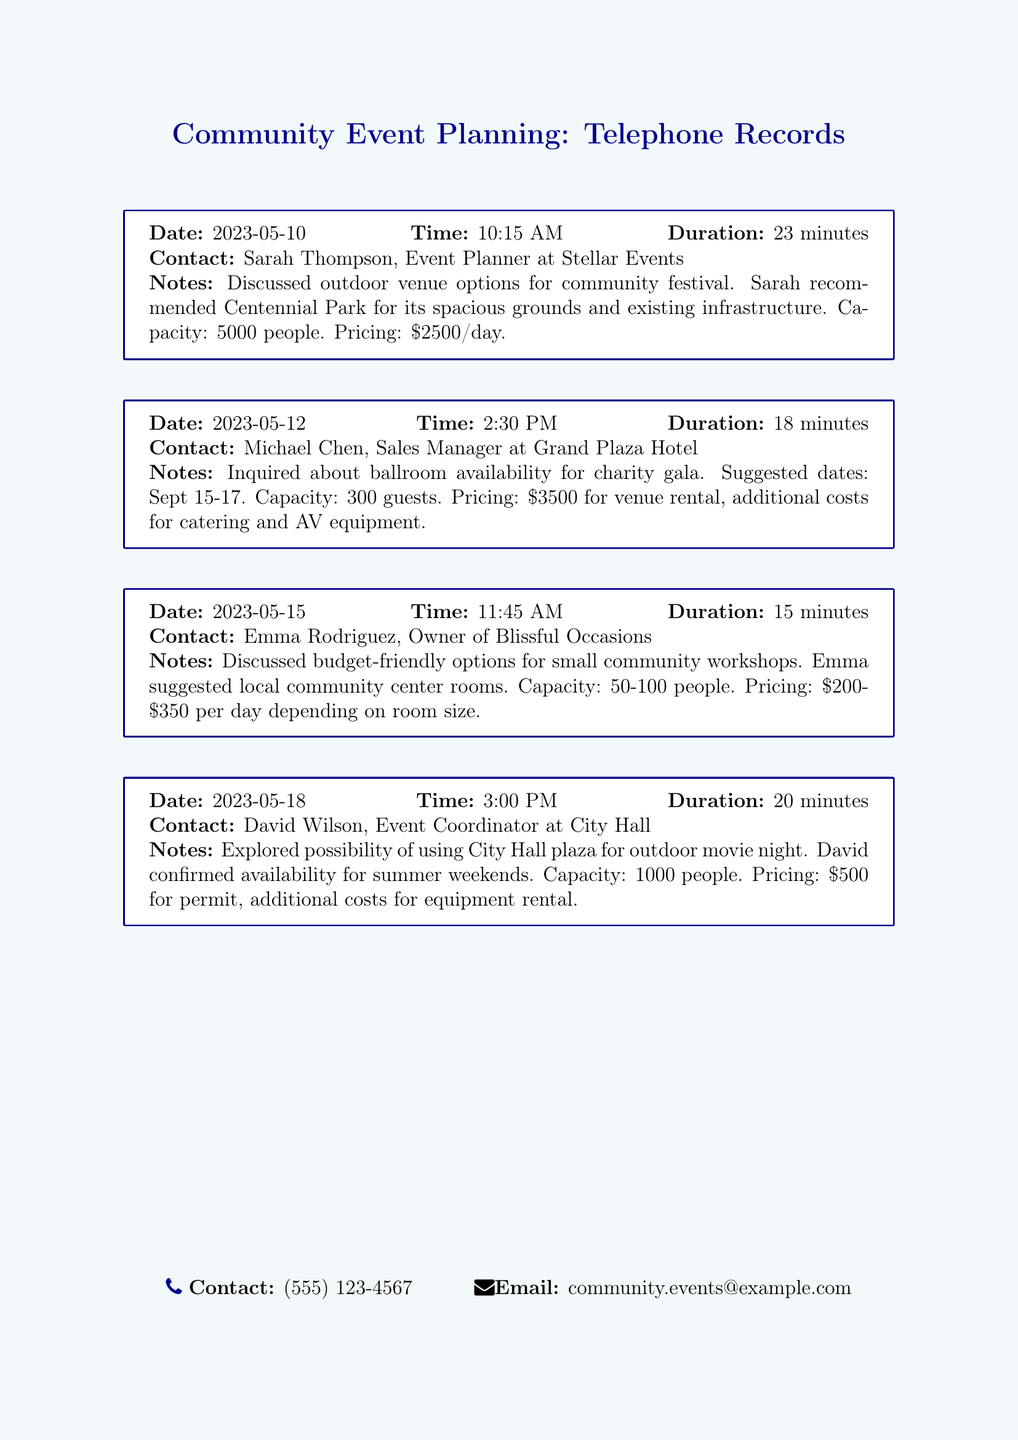What is the name of the event planner? The event planner mentioned in the document is Sarah Thompson from Stellar Events.
Answer: Sarah Thompson What is the capacity of the venue suggested by Emma Rodriguez? Emma Rodriguez suggested local community center rooms with a capacity of 50-100 people.
Answer: 50-100 people What is the pricing for using City Hall plaza? The pricing for using City Hall plaza is \$500 for the permit, with additional costs for equipment rental.
Answer: \$500 On what date were the options for a community festival discussed? The options for a community festival were discussed on May 10, 2023.
Answer: May 10, 2023 What type of event was Michael Chen inquiring about? Michael Chen was inquiring about a charity gala.
Answer: Charity gala How long was the call with David Wilson? The call with David Wilson lasted for 20 minutes.
Answer: 20 minutes What additional costs are associated with renting the ballroom? Additional costs for catering and AV equipment are associated with renting the ballroom.
Answer: Catering and AV equipment Which venue has a capacity of 5000 people? Centennial Park has a capacity of 5000 people.
Answer: Centennial Park What was the suggested date range for the charity gala? The suggested date range for the charity gala was September 15-17.
Answer: September 15-17 